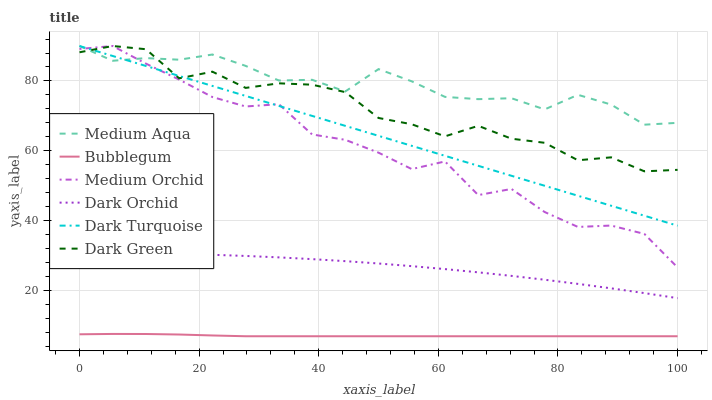Does Bubblegum have the minimum area under the curve?
Answer yes or no. Yes. Does Medium Aqua have the maximum area under the curve?
Answer yes or no. Yes. Does Medium Orchid have the minimum area under the curve?
Answer yes or no. No. Does Medium Orchid have the maximum area under the curve?
Answer yes or no. No. Is Dark Turquoise the smoothest?
Answer yes or no. Yes. Is Medium Orchid the roughest?
Answer yes or no. Yes. Is Dark Orchid the smoothest?
Answer yes or no. No. Is Dark Orchid the roughest?
Answer yes or no. No. Does Medium Orchid have the lowest value?
Answer yes or no. No. Does Dark Orchid have the highest value?
Answer yes or no. No. Is Bubblegum less than Medium Orchid?
Answer yes or no. Yes. Is Dark Turquoise greater than Dark Orchid?
Answer yes or no. Yes. Does Bubblegum intersect Medium Orchid?
Answer yes or no. No. 